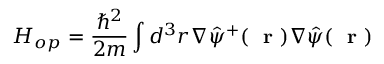<formula> <loc_0><loc_0><loc_500><loc_500>H _ { o p } = \frac { \hbar { ^ } { 2 } } { 2 m } \int d ^ { 3 } r \nabla \hat { \psi } ^ { + } ( r ) \nabla \hat { \psi } ( r )</formula> 